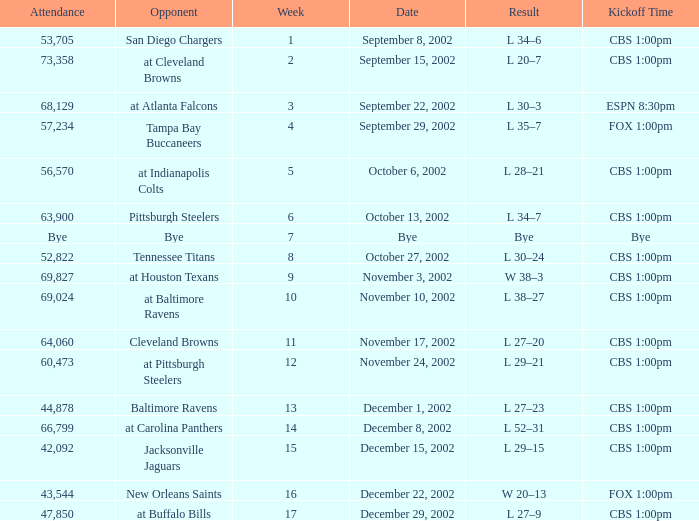What week number was the kickoff time cbs 1:00pm, with 60,473 people in attendance? 1.0. 